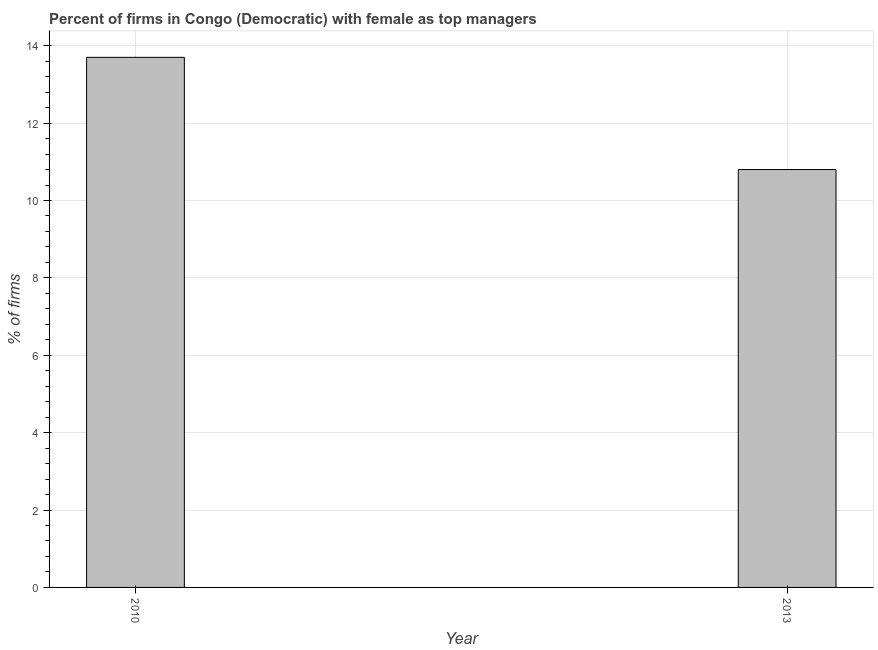Does the graph contain any zero values?
Provide a short and direct response. No. What is the title of the graph?
Give a very brief answer. Percent of firms in Congo (Democratic) with female as top managers. What is the label or title of the Y-axis?
Make the answer very short. % of firms. What is the percentage of firms with female as top manager in 2010?
Offer a very short reply. 13.7. Across all years, what is the maximum percentage of firms with female as top manager?
Provide a succinct answer. 13.7. In which year was the percentage of firms with female as top manager maximum?
Your answer should be compact. 2010. What is the difference between the percentage of firms with female as top manager in 2010 and 2013?
Keep it short and to the point. 2.9. What is the average percentage of firms with female as top manager per year?
Give a very brief answer. 12.25. What is the median percentage of firms with female as top manager?
Offer a terse response. 12.25. Do a majority of the years between 2010 and 2013 (inclusive) have percentage of firms with female as top manager greater than 13.2 %?
Make the answer very short. No. What is the ratio of the percentage of firms with female as top manager in 2010 to that in 2013?
Your answer should be compact. 1.27. Are all the bars in the graph horizontal?
Provide a succinct answer. No. What is the difference between two consecutive major ticks on the Y-axis?
Ensure brevity in your answer.  2. What is the % of firms of 2013?
Make the answer very short. 10.8. What is the ratio of the % of firms in 2010 to that in 2013?
Your answer should be very brief. 1.27. 